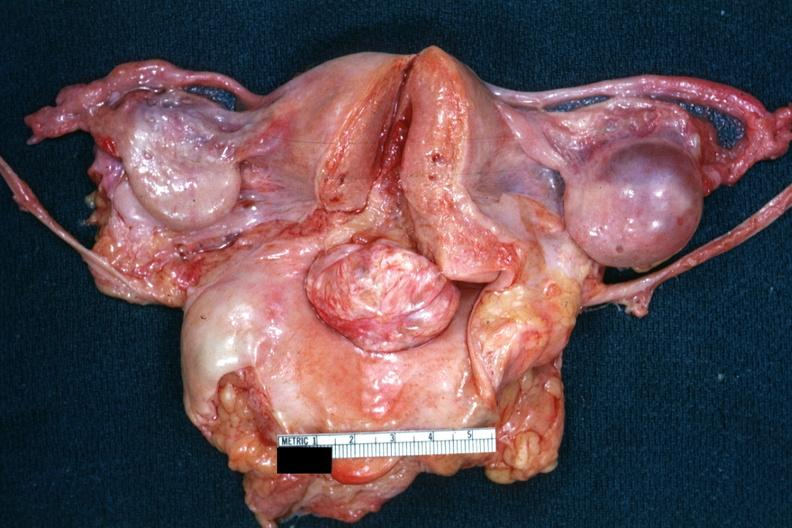s cervical leiomyoma present?
Answer the question using a single word or phrase. Yes 